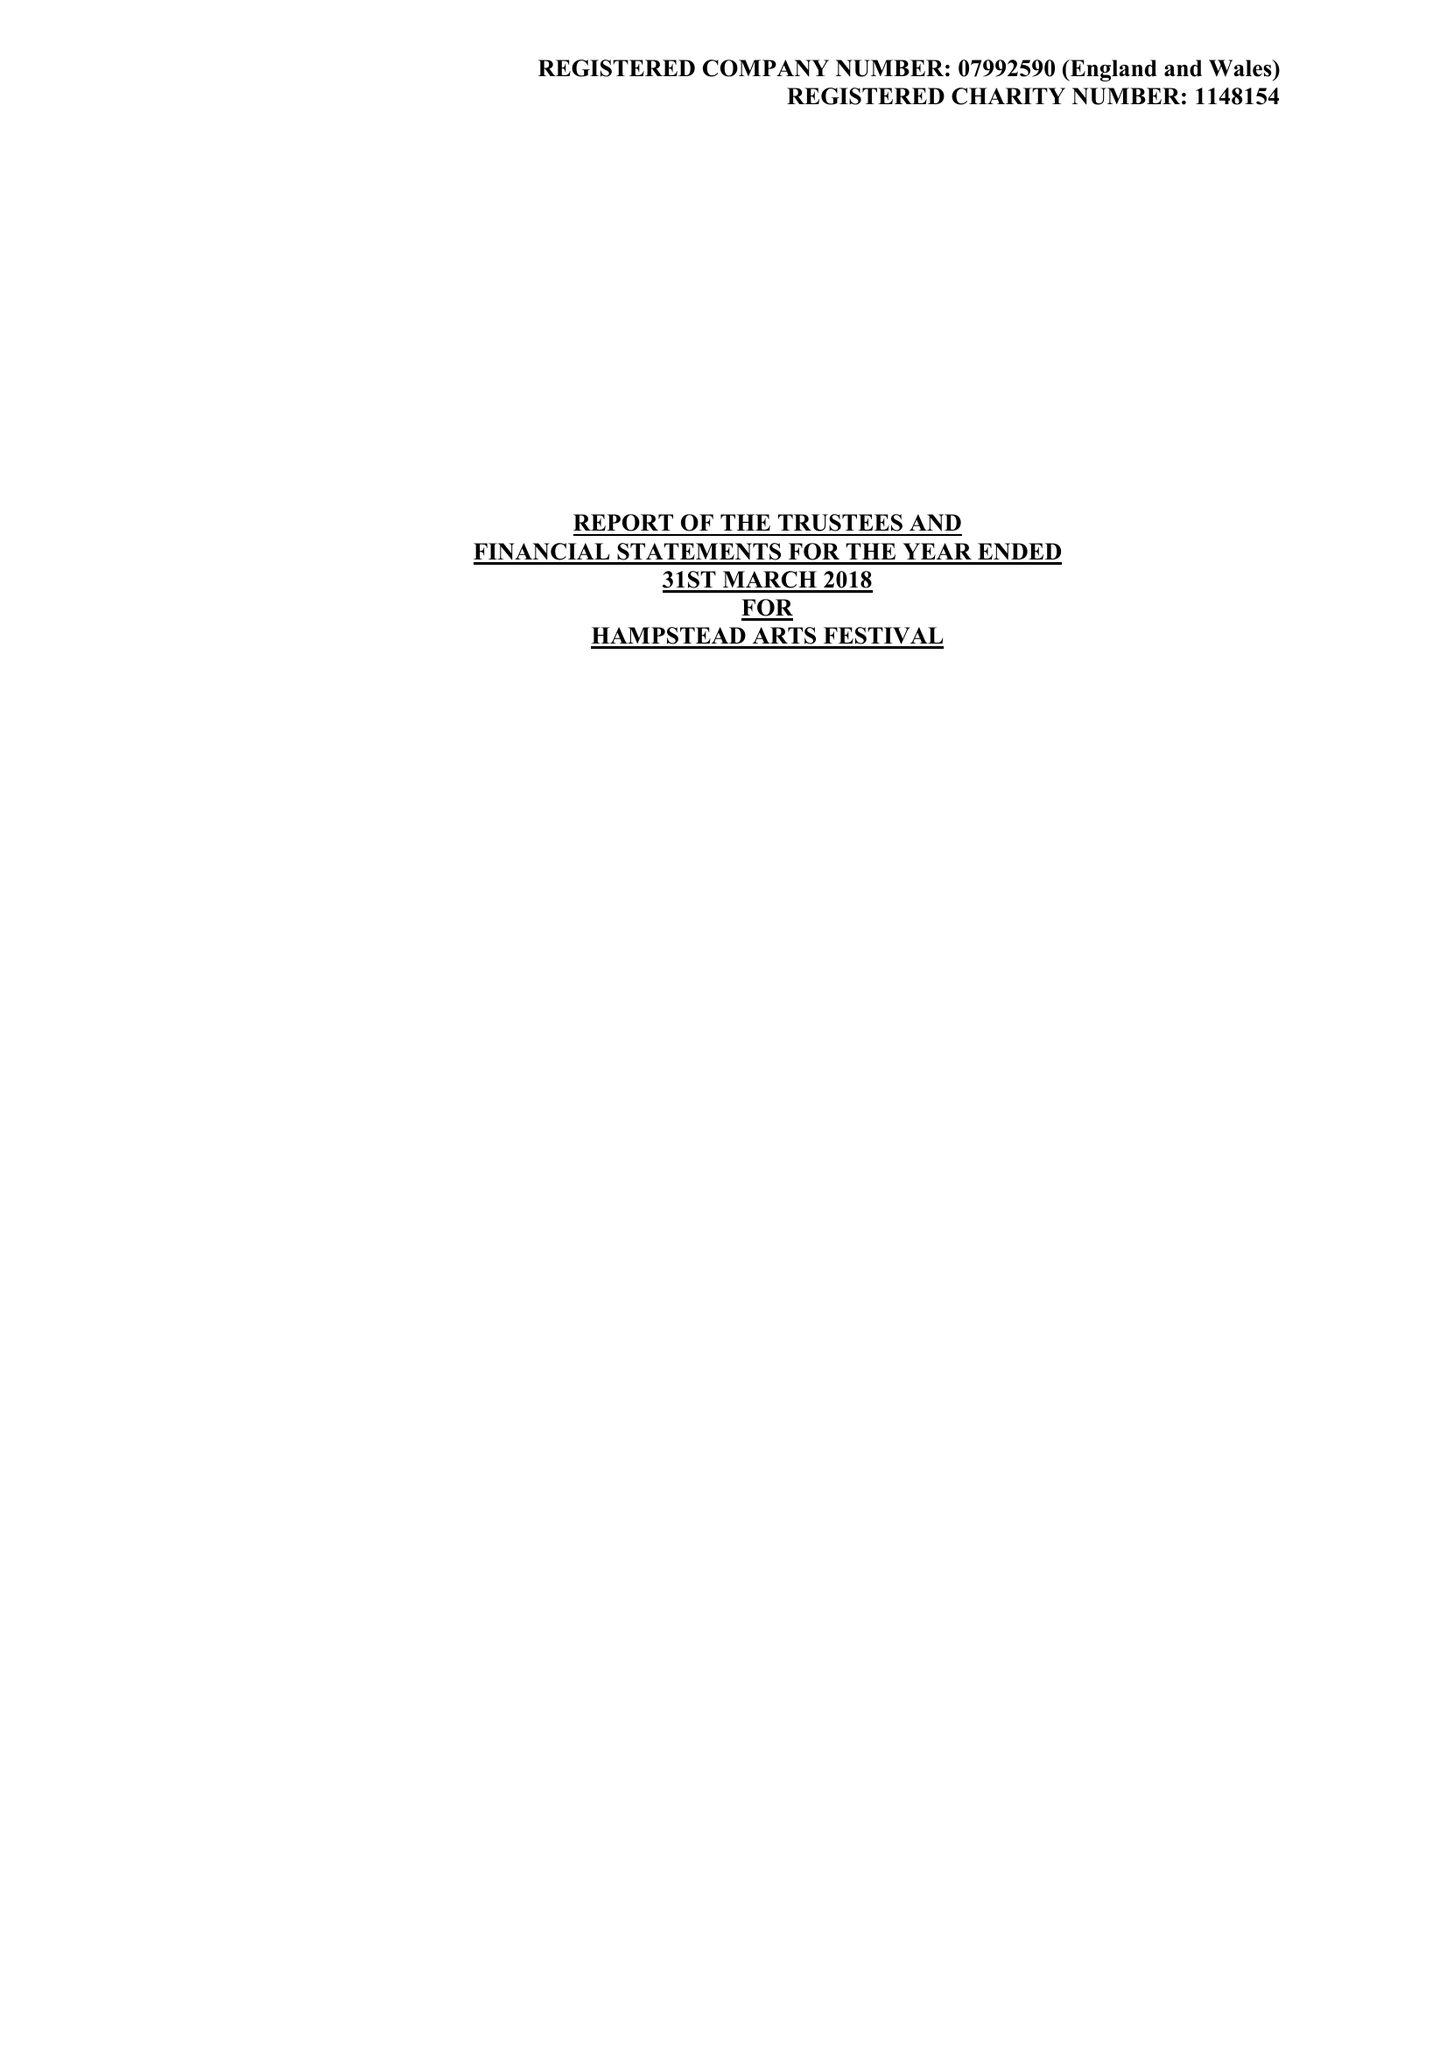What is the value for the address__street_line?
Answer the question using a single word or phrase. 31/33 COLLEGE ROAD 